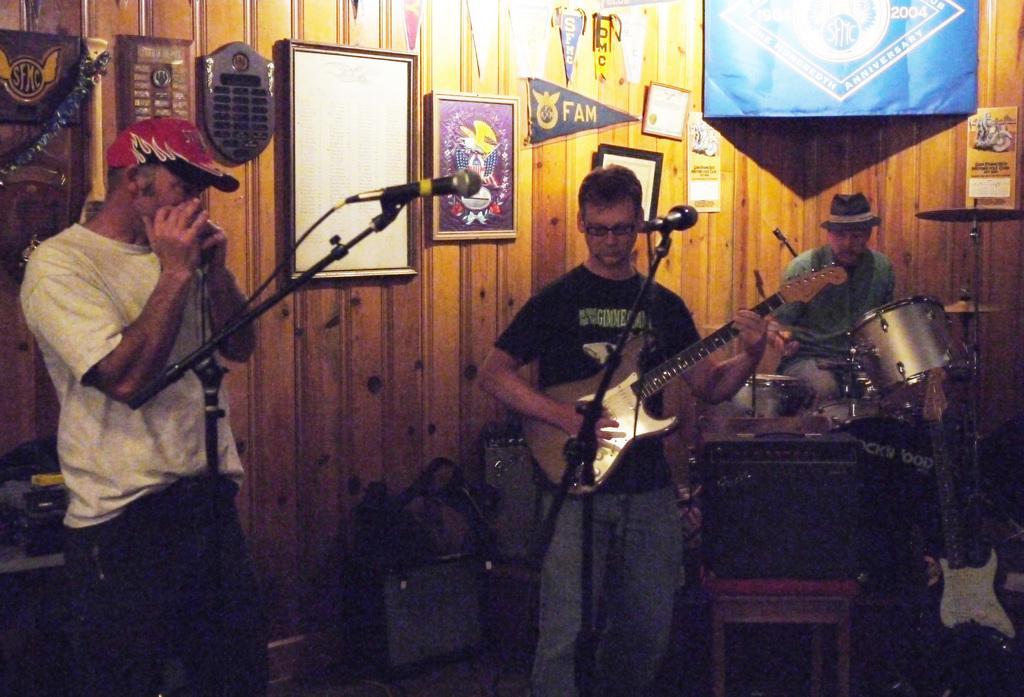How would you summarize this image in a sentence or two? These two persons standing. This person sitting and playing musical instrument. This person holding guitar. There is a microphones with stand. On the background we can see wall,frames,banner. we can see chairs. 